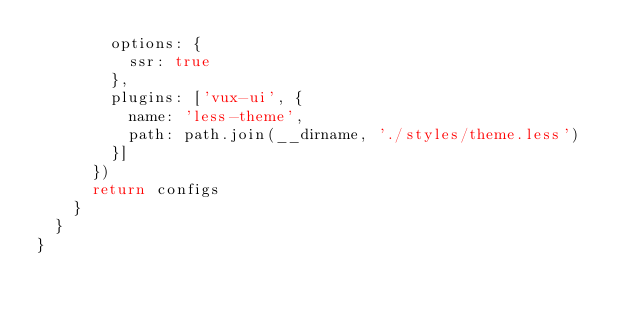Convert code to text. <code><loc_0><loc_0><loc_500><loc_500><_JavaScript_>        options: {
          ssr: true
        },
        plugins: ['vux-ui', {
          name: 'less-theme',
          path: path.join(__dirname, './styles/theme.less')
        }]
      })
      return configs
    }
  }
}
</code> 